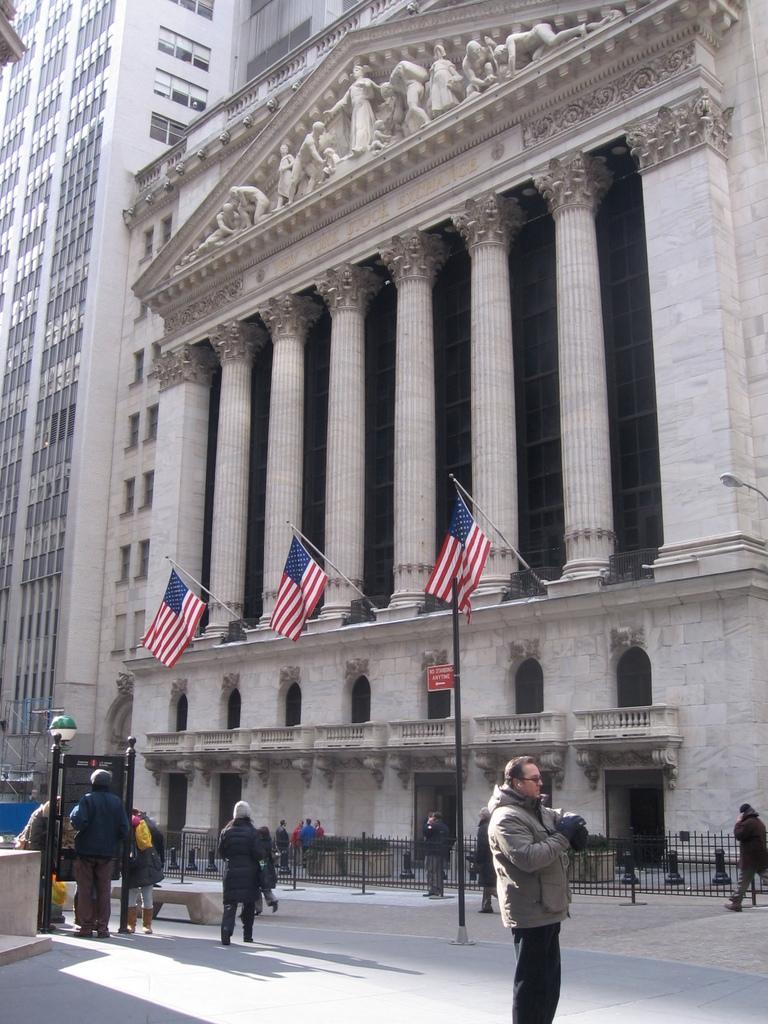How would you summarize this image in a sentence or two? At the bottom there is a man who is wearing goggle, jacket, t-shirt, gloves and trouser. In the bottom left corner we can see the group of persons standing near to the board and wall. On the right there is a man who is walking on the street, beside him we can see the black fencing. In front of the building we can see the group of persons were standing. On this building there are three flags. At the top of the building we can see the statues of the persons. On the left we can see the skyscraper. 